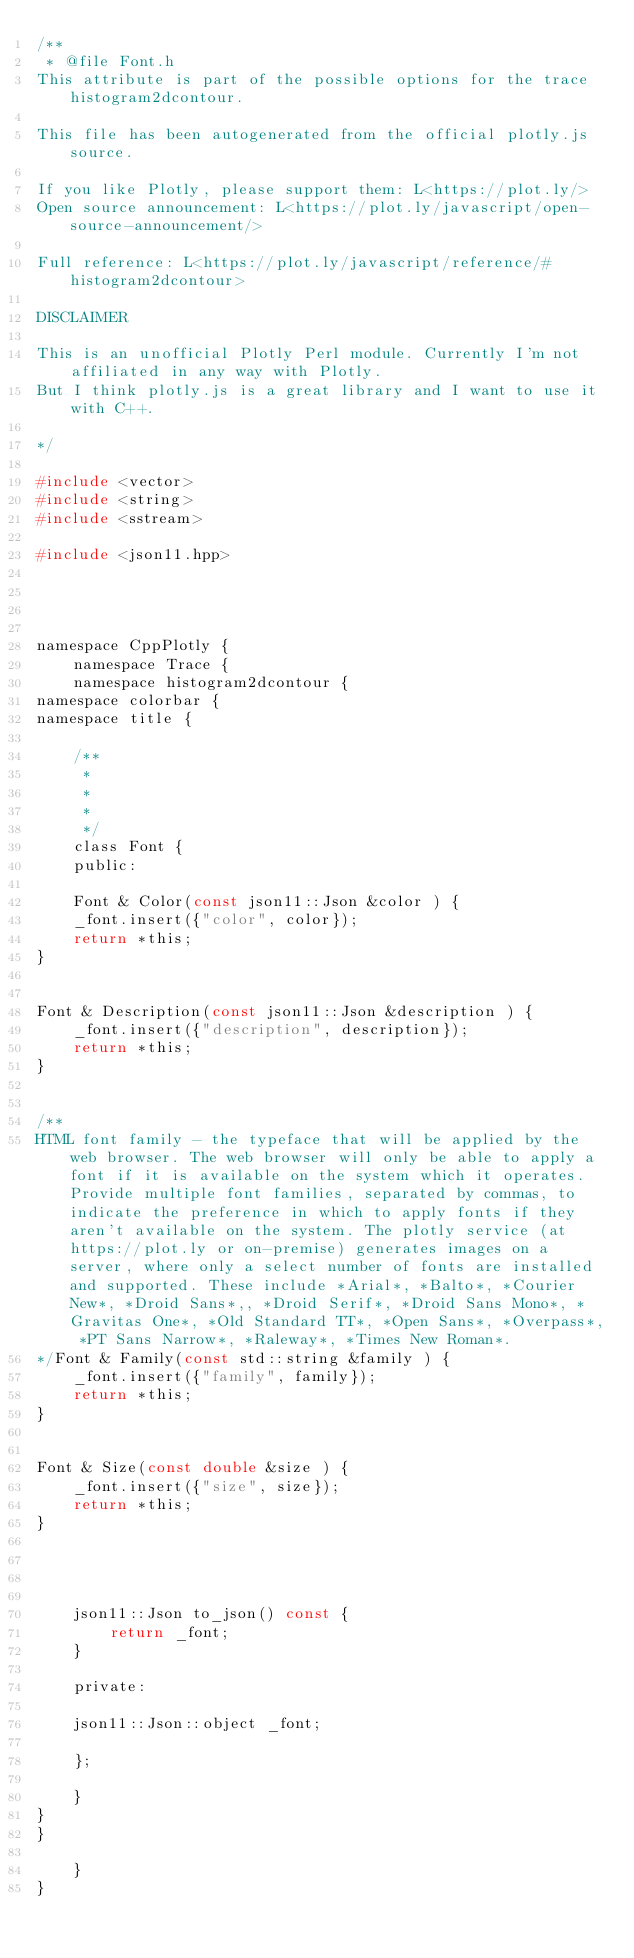<code> <loc_0><loc_0><loc_500><loc_500><_C_>/**
 * @file Font.h
This attribute is part of the possible options for the trace histogram2dcontour.

This file has been autogenerated from the official plotly.js source.

If you like Plotly, please support them: L<https://plot.ly/> 
Open source announcement: L<https://plot.ly/javascript/open-source-announcement/>

Full reference: L<https://plot.ly/javascript/reference/#histogram2dcontour>

DISCLAIMER

This is an unofficial Plotly Perl module. Currently I'm not affiliated in any way with Plotly. 
But I think plotly.js is a great library and I want to use it with C++.

*/

#include <vector>
#include <string>
#include <sstream>

#include <json11.hpp>




namespace CppPlotly {
    namespace Trace {
    namespace histogram2dcontour {
namespace colorbar {
namespace title {

    /**
     * 
     *
     *
     */
    class Font {
    public:

    Font & Color(const json11::Json &color ) {
    _font.insert({"color", color});
    return *this;
}


Font & Description(const json11::Json &description ) {
    _font.insert({"description", description});
    return *this;
}


/**
HTML font family - the typeface that will be applied by the web browser. The web browser will only be able to apply a font if it is available on the system which it operates. Provide multiple font families, separated by commas, to indicate the preference in which to apply fonts if they aren't available on the system. The plotly service (at https://plot.ly or on-premise) generates images on a server, where only a select number of fonts are installed and supported. These include *Arial*, *Balto*, *Courier New*, *Droid Sans*,, *Droid Serif*, *Droid Sans Mono*, *Gravitas One*, *Old Standard TT*, *Open Sans*, *Overpass*, *PT Sans Narrow*, *Raleway*, *Times New Roman*.
*/Font & Family(const std::string &family ) {
    _font.insert({"family", family});
    return *this;
}


Font & Size(const double &size ) {
    _font.insert({"size", size});
    return *this;
}




    json11::Json to_json() const {
        return _font;
    }

    private:

    json11::Json::object _font;

    };

    }
}
}

    }
}
</code> 